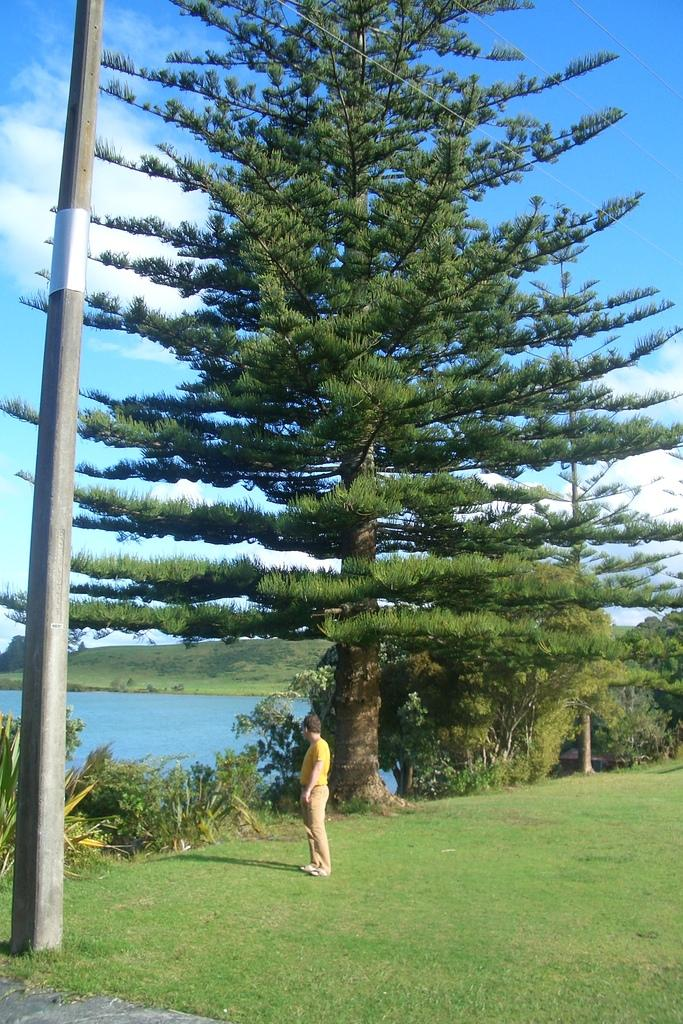What is the main subject of the image? There is a person standing in the image. What is the color and texture of the ground in the image? The ground is green and grassy. What can be seen behind the person in the image? There are trees behind the person. What is the body of water visible in the image? There is water visible in the image. What object is located in the left corner of the image? There is a pole in the left corner of the image. How many apples are being used for learning in the image? There are no apples or any learning activity depicted in the image. When was the person's birth in the image? The image does not provide any information about the person's birth. 